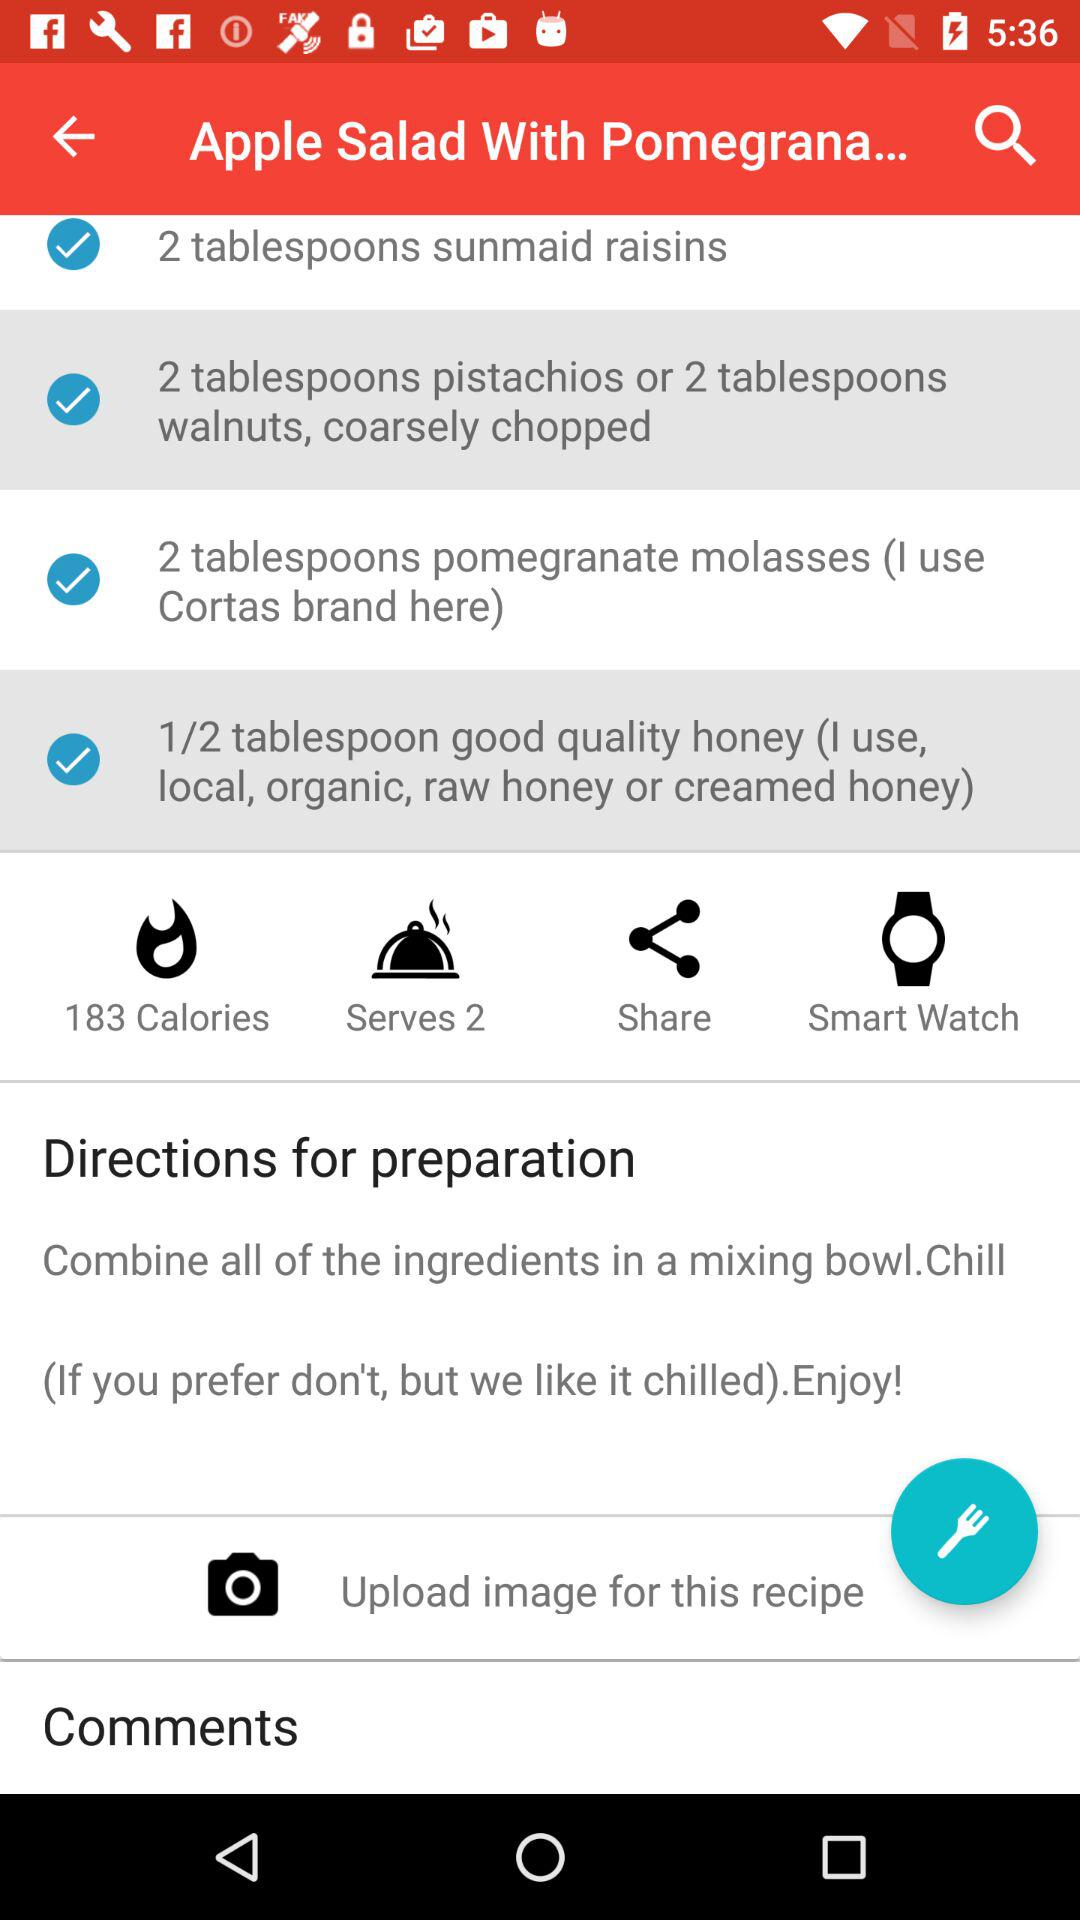How many grams of fat are in "Apple Salad With Pomegrana..."?
When the provided information is insufficient, respond with <no answer>. <no answer> 